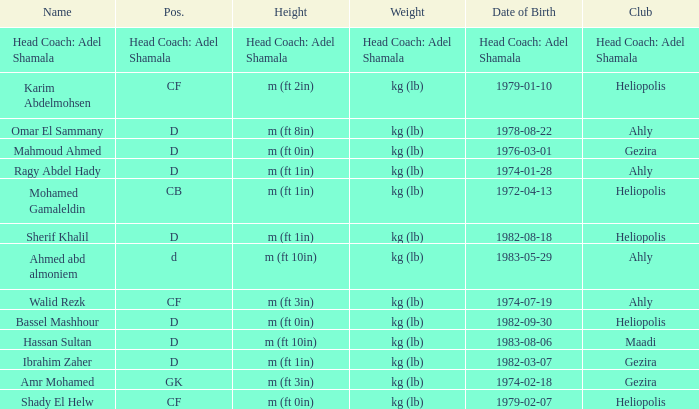What is Name, when Weight is "kg (lb)", when Club is "Gezira", and when Date of Birth is "1974-02-18"? Amr Mohamed. 